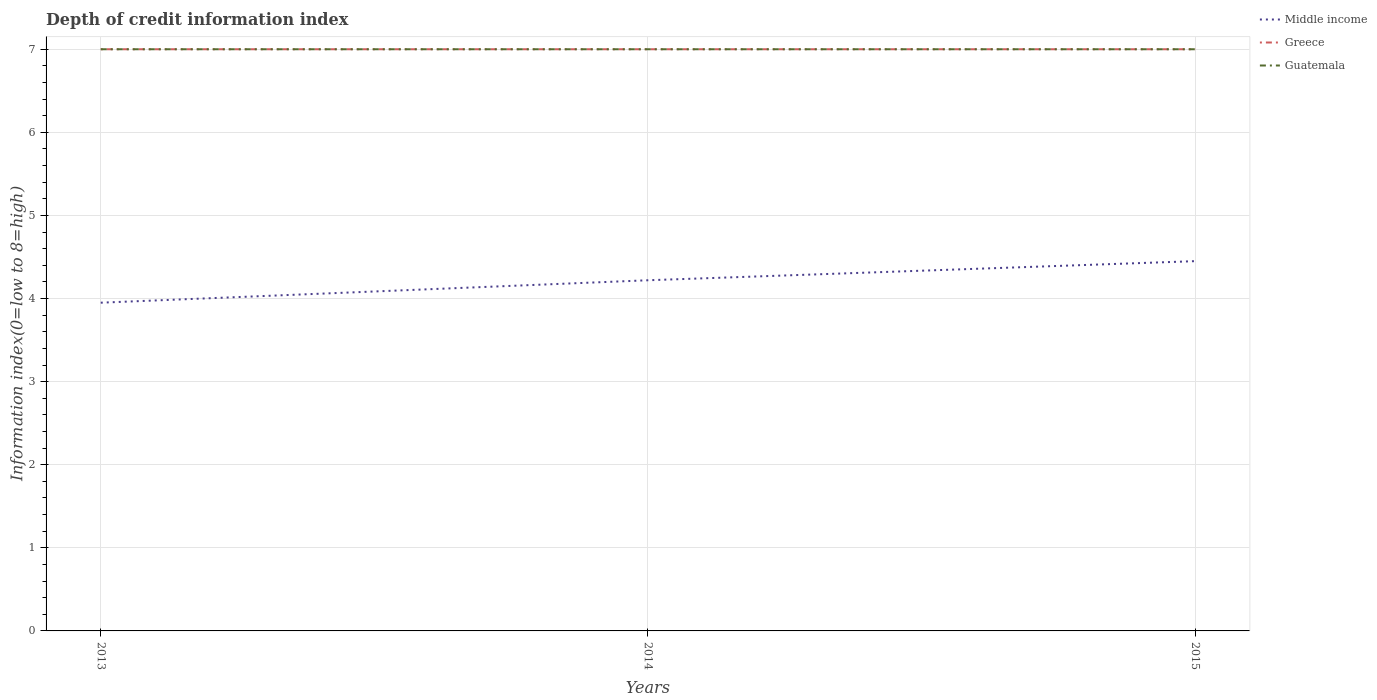Does the line corresponding to Guatemala intersect with the line corresponding to Middle income?
Provide a short and direct response. No. Across all years, what is the maximum information index in Greece?
Make the answer very short. 7. In which year was the information index in Guatemala maximum?
Make the answer very short. 2013. What is the difference between the highest and the lowest information index in Guatemala?
Your response must be concise. 0. How many years are there in the graph?
Your response must be concise. 3. Are the values on the major ticks of Y-axis written in scientific E-notation?
Provide a succinct answer. No. Does the graph contain any zero values?
Make the answer very short. No. Where does the legend appear in the graph?
Your response must be concise. Top right. What is the title of the graph?
Your answer should be compact. Depth of credit information index. Does "Belarus" appear as one of the legend labels in the graph?
Your response must be concise. No. What is the label or title of the Y-axis?
Ensure brevity in your answer.  Information index(0=low to 8=high). What is the Information index(0=low to 8=high) in Middle income in 2013?
Provide a succinct answer. 3.95. What is the Information index(0=low to 8=high) of Greece in 2013?
Make the answer very short. 7. What is the Information index(0=low to 8=high) in Guatemala in 2013?
Give a very brief answer. 7. What is the Information index(0=low to 8=high) in Middle income in 2014?
Your response must be concise. 4.22. What is the Information index(0=low to 8=high) of Greece in 2014?
Your answer should be very brief. 7. What is the Information index(0=low to 8=high) of Guatemala in 2014?
Keep it short and to the point. 7. What is the Information index(0=low to 8=high) of Middle income in 2015?
Ensure brevity in your answer.  4.45. What is the Information index(0=low to 8=high) of Greece in 2015?
Your answer should be compact. 7. Across all years, what is the maximum Information index(0=low to 8=high) of Middle income?
Ensure brevity in your answer.  4.45. Across all years, what is the maximum Information index(0=low to 8=high) in Greece?
Provide a short and direct response. 7. Across all years, what is the minimum Information index(0=low to 8=high) in Middle income?
Your answer should be very brief. 3.95. Across all years, what is the minimum Information index(0=low to 8=high) in Greece?
Ensure brevity in your answer.  7. What is the total Information index(0=low to 8=high) in Middle income in the graph?
Offer a very short reply. 12.62. What is the total Information index(0=low to 8=high) in Greece in the graph?
Provide a short and direct response. 21. What is the difference between the Information index(0=low to 8=high) in Middle income in 2013 and that in 2014?
Your response must be concise. -0.27. What is the difference between the Information index(0=low to 8=high) in Greece in 2013 and that in 2014?
Your answer should be very brief. 0. What is the difference between the Information index(0=low to 8=high) in Middle income in 2013 and that in 2015?
Provide a succinct answer. -0.5. What is the difference between the Information index(0=low to 8=high) of Middle income in 2014 and that in 2015?
Offer a terse response. -0.23. What is the difference between the Information index(0=low to 8=high) in Greece in 2014 and that in 2015?
Offer a terse response. 0. What is the difference between the Information index(0=low to 8=high) in Guatemala in 2014 and that in 2015?
Your answer should be compact. 0. What is the difference between the Information index(0=low to 8=high) in Middle income in 2013 and the Information index(0=low to 8=high) in Greece in 2014?
Your answer should be very brief. -3.05. What is the difference between the Information index(0=low to 8=high) in Middle income in 2013 and the Information index(0=low to 8=high) in Guatemala in 2014?
Offer a terse response. -3.05. What is the difference between the Information index(0=low to 8=high) in Greece in 2013 and the Information index(0=low to 8=high) in Guatemala in 2014?
Provide a succinct answer. 0. What is the difference between the Information index(0=low to 8=high) of Middle income in 2013 and the Information index(0=low to 8=high) of Greece in 2015?
Offer a terse response. -3.05. What is the difference between the Information index(0=low to 8=high) in Middle income in 2013 and the Information index(0=low to 8=high) in Guatemala in 2015?
Keep it short and to the point. -3.05. What is the difference between the Information index(0=low to 8=high) of Greece in 2013 and the Information index(0=low to 8=high) of Guatemala in 2015?
Make the answer very short. 0. What is the difference between the Information index(0=low to 8=high) of Middle income in 2014 and the Information index(0=low to 8=high) of Greece in 2015?
Keep it short and to the point. -2.78. What is the difference between the Information index(0=low to 8=high) in Middle income in 2014 and the Information index(0=low to 8=high) in Guatemala in 2015?
Give a very brief answer. -2.78. What is the difference between the Information index(0=low to 8=high) of Greece in 2014 and the Information index(0=low to 8=high) of Guatemala in 2015?
Your response must be concise. 0. What is the average Information index(0=low to 8=high) in Middle income per year?
Offer a terse response. 4.21. What is the average Information index(0=low to 8=high) of Greece per year?
Ensure brevity in your answer.  7. What is the average Information index(0=low to 8=high) of Guatemala per year?
Offer a very short reply. 7. In the year 2013, what is the difference between the Information index(0=low to 8=high) of Middle income and Information index(0=low to 8=high) of Greece?
Provide a short and direct response. -3.05. In the year 2013, what is the difference between the Information index(0=low to 8=high) of Middle income and Information index(0=low to 8=high) of Guatemala?
Offer a very short reply. -3.05. In the year 2014, what is the difference between the Information index(0=low to 8=high) of Middle income and Information index(0=low to 8=high) of Greece?
Ensure brevity in your answer.  -2.78. In the year 2014, what is the difference between the Information index(0=low to 8=high) in Middle income and Information index(0=low to 8=high) in Guatemala?
Your answer should be very brief. -2.78. In the year 2014, what is the difference between the Information index(0=low to 8=high) of Greece and Information index(0=low to 8=high) of Guatemala?
Provide a succinct answer. 0. In the year 2015, what is the difference between the Information index(0=low to 8=high) in Middle income and Information index(0=low to 8=high) in Greece?
Offer a very short reply. -2.55. In the year 2015, what is the difference between the Information index(0=low to 8=high) of Middle income and Information index(0=low to 8=high) of Guatemala?
Give a very brief answer. -2.55. What is the ratio of the Information index(0=low to 8=high) of Middle income in 2013 to that in 2014?
Make the answer very short. 0.94. What is the ratio of the Information index(0=low to 8=high) of Greece in 2013 to that in 2014?
Ensure brevity in your answer.  1. What is the ratio of the Information index(0=low to 8=high) of Guatemala in 2013 to that in 2014?
Keep it short and to the point. 1. What is the ratio of the Information index(0=low to 8=high) of Middle income in 2013 to that in 2015?
Keep it short and to the point. 0.89. What is the ratio of the Information index(0=low to 8=high) of Greece in 2013 to that in 2015?
Offer a very short reply. 1. What is the ratio of the Information index(0=low to 8=high) in Middle income in 2014 to that in 2015?
Give a very brief answer. 0.95. What is the ratio of the Information index(0=low to 8=high) in Guatemala in 2014 to that in 2015?
Offer a very short reply. 1. What is the difference between the highest and the second highest Information index(0=low to 8=high) in Middle income?
Offer a very short reply. 0.23. What is the difference between the highest and the lowest Information index(0=low to 8=high) in Middle income?
Ensure brevity in your answer.  0.5. What is the difference between the highest and the lowest Information index(0=low to 8=high) of Greece?
Give a very brief answer. 0. What is the difference between the highest and the lowest Information index(0=low to 8=high) in Guatemala?
Provide a succinct answer. 0. 